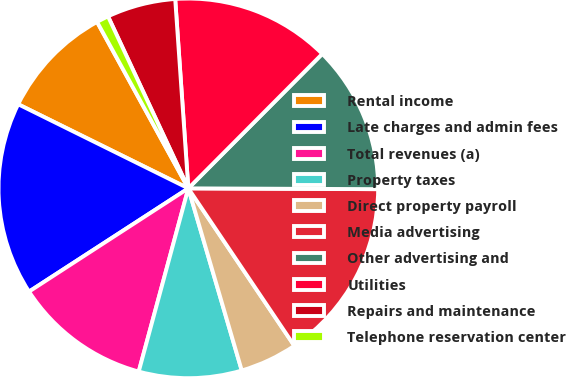Convert chart. <chart><loc_0><loc_0><loc_500><loc_500><pie_chart><fcel>Rental income<fcel>Late charges and admin fees<fcel>Total revenues (a)<fcel>Property taxes<fcel>Direct property payroll<fcel>Media advertising<fcel>Other advertising and<fcel>Utilities<fcel>Repairs and maintenance<fcel>Telephone reservation center<nl><fcel>9.71%<fcel>16.46%<fcel>11.64%<fcel>8.75%<fcel>4.89%<fcel>15.5%<fcel>12.6%<fcel>13.57%<fcel>5.85%<fcel>1.03%<nl></chart> 